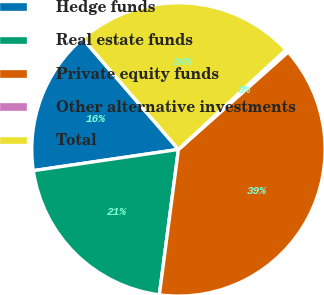Convert chart. <chart><loc_0><loc_0><loc_500><loc_500><pie_chart><fcel>Hedge funds<fcel>Real estate funds<fcel>Private equity funds<fcel>Other alternative investments<fcel>Total<nl><fcel>15.97%<fcel>20.61%<fcel>38.64%<fcel>0.34%<fcel>24.44%<nl></chart> 